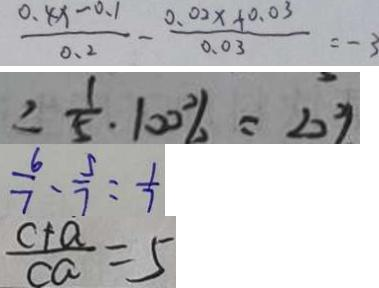Convert formula to latex. <formula><loc_0><loc_0><loc_500><loc_500>\frac { 0 . 8 x - 0 . 1 } { 0 . 2 } - \frac { 0 . 0 2 x + 0 . 0 3 } { 0 . 0 3 } = - 3 
 \frac { 1 } { 5 } \cdot 1 0 0 \% = 2 0 \% 
 \frac { 6 } { 7 } - \frac { 5 } { 7 } = \frac { 1 } { 7 } 
 \frac { c + a } { c a } = 5</formula> 